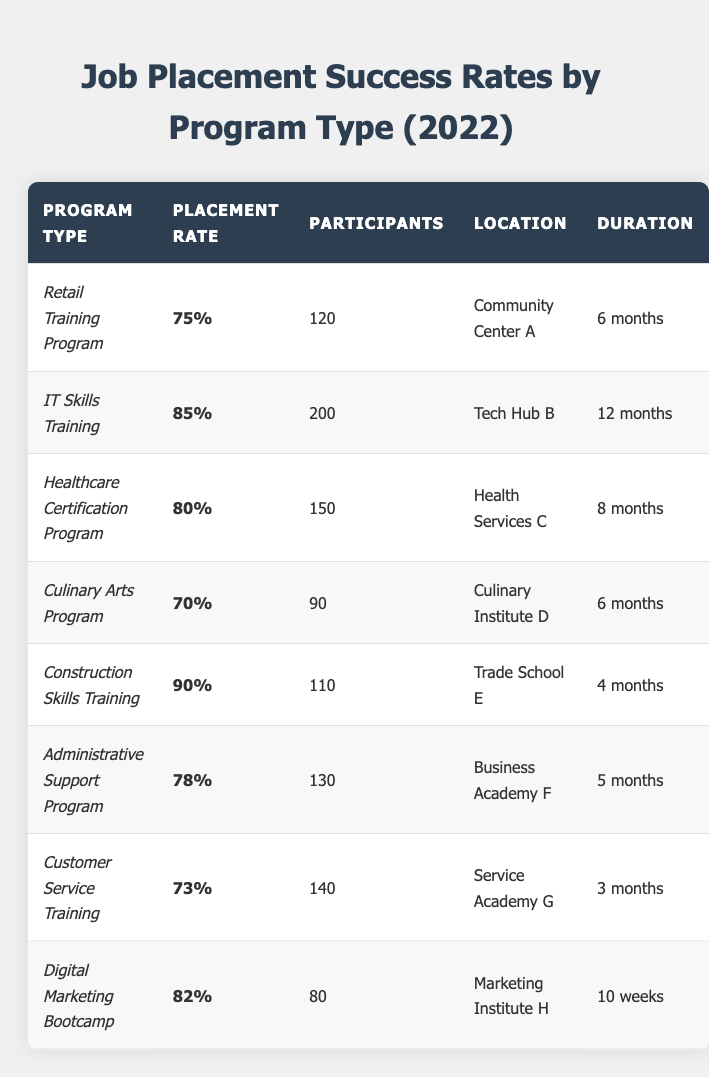What is the placement rate for the IT Skills Training program? The IT Skills Training program has a placement rate of 85% as stated in the table.
Answer: 85% Which program had the highest placement rate? The program with the highest placement rate is the Construction Skills Training, with a rate of 90%.
Answer: Construction Skills Training How many participants were involved in the Culinary Arts Program? The Culinary Arts Program had 90 participants, as shown in the table.
Answer: 90 What is the average placement rate of all programs listed? The placement rates are 75%, 85%, 80%, 70%, 90%, 78%, 73%, and 82%. Adding them gives 75 + 85 + 80 + 70 + 90 + 78 + 73 + 82 = 633. There are 8 programs, so the average is 633 / 8 = 79.125%.
Answer: 79.125% How many participants did the Digital Marketing Bootcamp have? The Digital Marketing Bootcamp had 80 participants according to the table.
Answer: 80 Is the Healthcare Certification Program more effective than the Customer Service Training based on placement rates? The Healthcare Certification Program has a placement rate of 80%, while the Customer Service Training has a rate of 73%. Since 80% is greater than 73%, the Healthcare Certification Program is more effective.
Answer: Yes What is the total number of participants across all programs? The total number of participants can be calculated by adding all participants: 120 (Retail) + 200 (IT) + 150 (Healthcare) + 90 (Culinary) + 110 (Construction) + 130 (Administrative) + 140 (Customer Service) + 80 (Digital Marketing) = 1,120.
Answer: 1,120 Which program type has the shortest duration? The Customer Service Training program has the shortest duration of 3 months.
Answer: Customer Service Training Is there a program with a placement rate of 90%? Yes, the Construction Skills Training program has a placement rate of 90%.
Answer: Yes How does the placement rate of the Administrative Support Program compare with the Culinary Arts Program? The Administrative Support Program has a placement rate of 78%, while the Culinary Arts Program has a rate of 70%. Since 78% is greater than 70%, the Administrative Support Program is more successful.
Answer: Administrative Support Program is more successful 